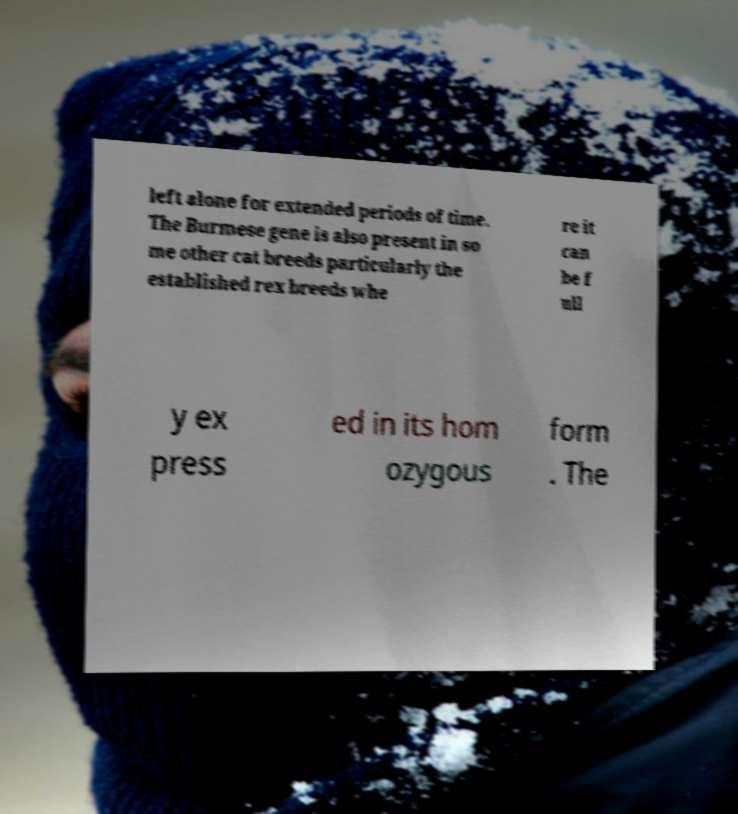Can you accurately transcribe the text from the provided image for me? left alone for extended periods of time. The Burmese gene is also present in so me other cat breeds particularly the established rex breeds whe re it can be f ull y ex press ed in its hom ozygous form . The 